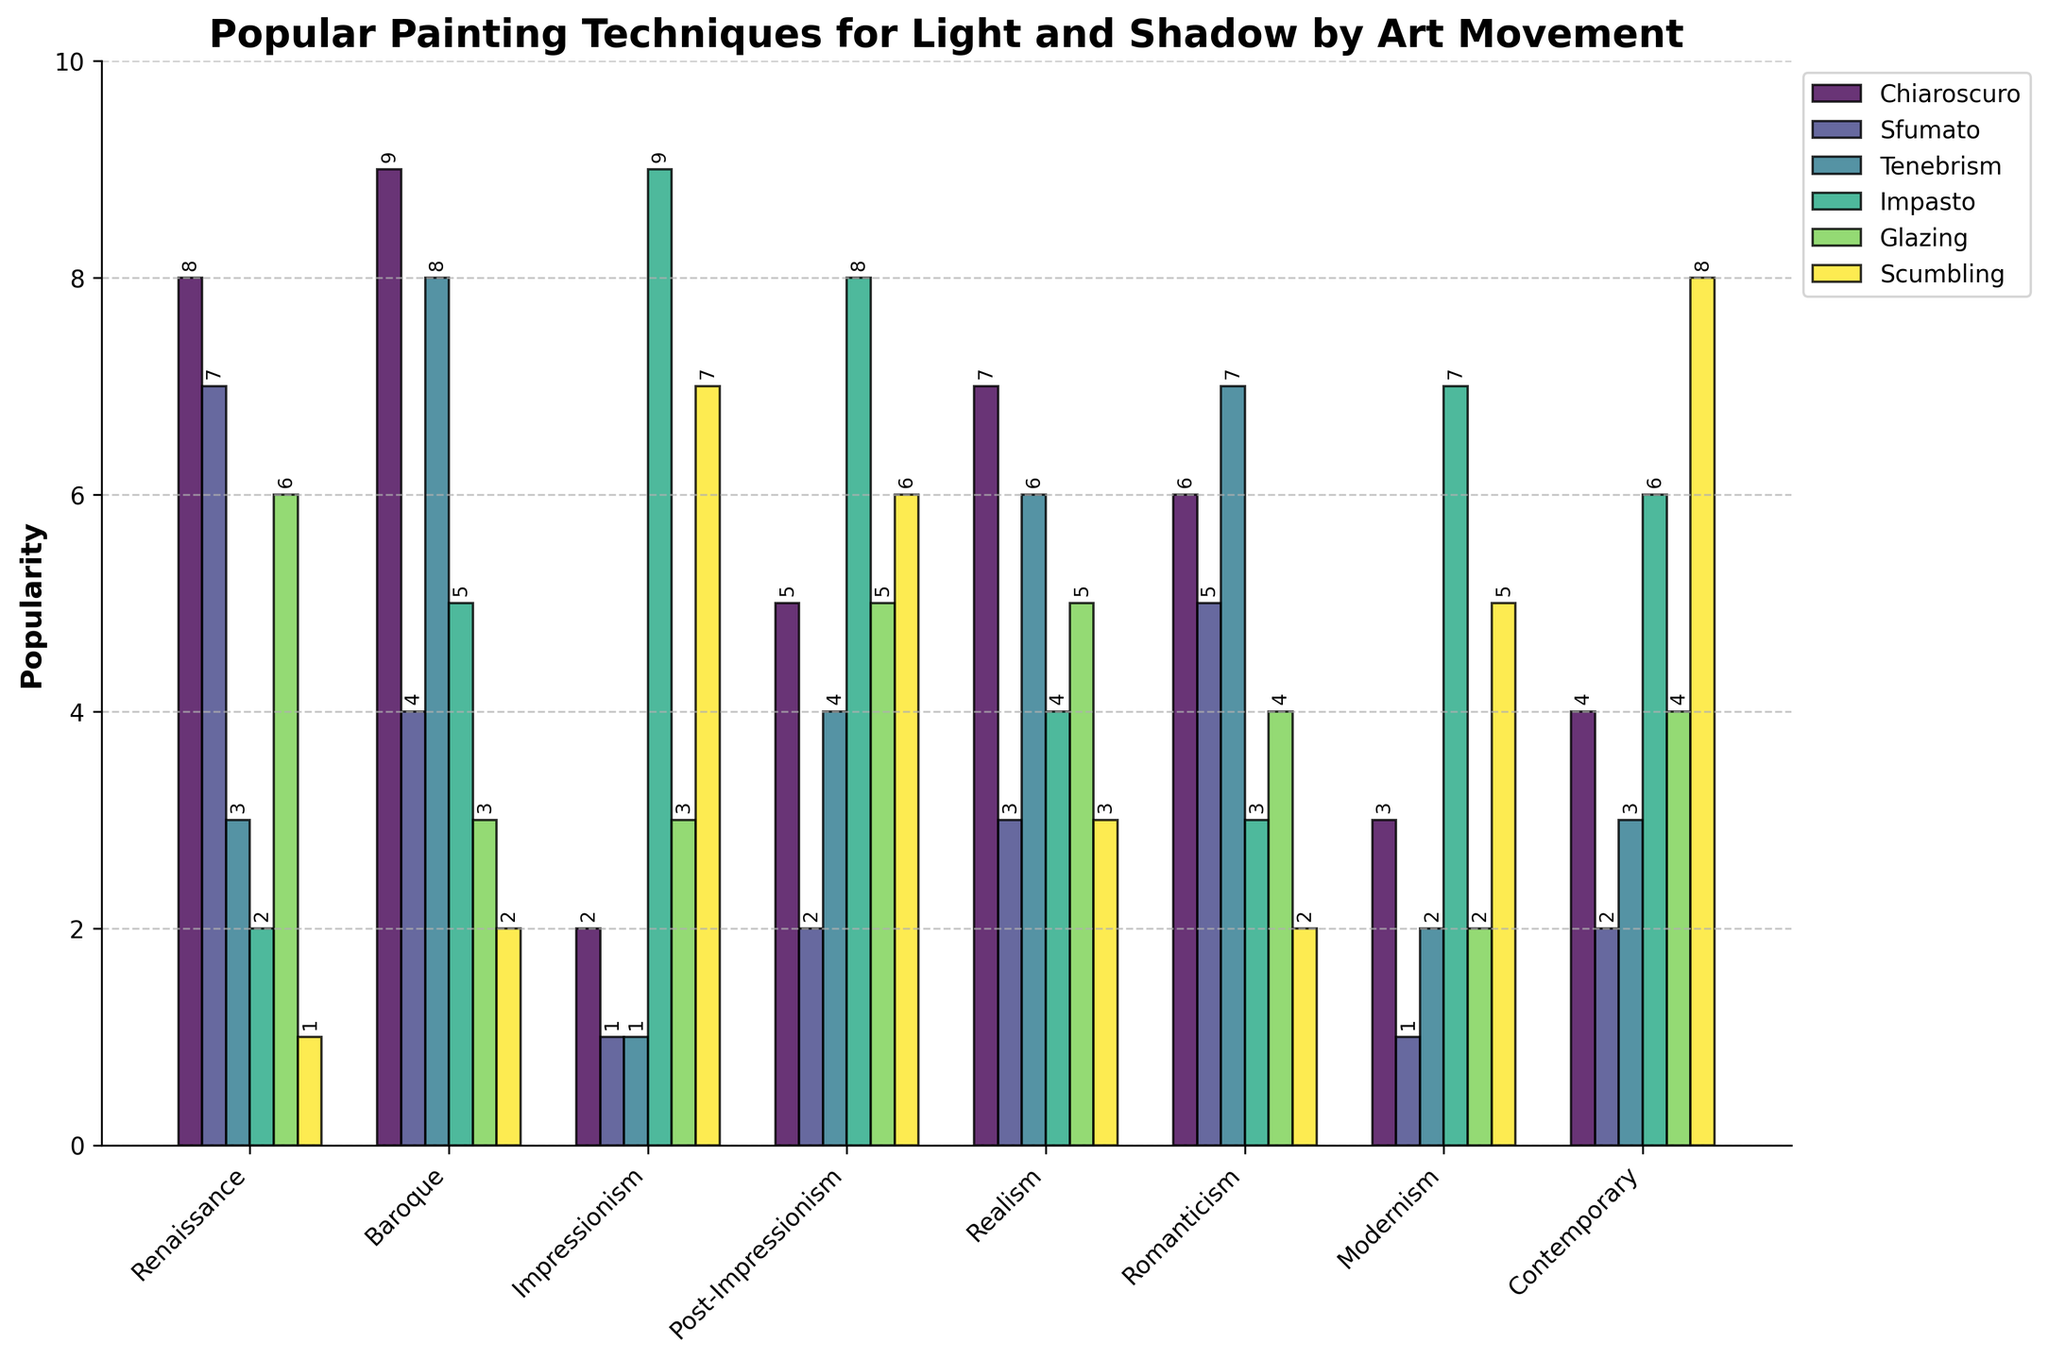What is the most popular painting technique used in the Baroque period? By examining the height of the bars for each technique in the Baroque period, we see that "Chiaroscuro" has the highest bar, which indicates it is the most popular technique.
Answer: Chiaroscuro Which art movement uses Impasto more frequently: Impressionism or Realism? Comparing the height of the Impasto bars for both movements, we see that the Impressionism bar is taller (9) than the Realism bar (4).
Answer: Impressionism In which art movement is Sfumato used the least? We need to find the shortest bar for Sfumato across all movements. The shortest bar corresponds to the Impressionism movement with a value of 1.
Answer: Impressionism What is the average popularity of Glazing across all art movements? Sum the values of Glazing across all movements (6+3+3+5+5+4+2+4) = 32, and then divide by the number of groups (8). The average is 32/8 = 4.
Answer: 4 How does the popularity of Tenebrism in Romanticism compare to that in Contemporary art? By comparing the height of the Tenebrism bars, Romanticism has a bar value of 7, and Contemporary has a bar value of 3, indicating that Tenebrism is more popular in Romanticism.
Answer: Romanticism is higher Which painting technique has a consistent popularity across all art movements, based on visual observation? Observing the bar heights visually, Scumbling appears relatively consistent, maintaining moderate values with minor variations.
Answer: Scumbling What is the total number of times Chiaroscuro is used in the Renaissance and Baroque periods combined? Adding the values of Chiaroscuro for both periods (8 for Renaissance + 9 for Baroque) gives us 17.
Answer: 17 How does the popularity of Scumbling in Contemporary art compare to its popularity in Modernism? Comparing the heights of the Scumbling bars, Contemporary has a value of 8, while Modernism has a value of 5, indicating it is more popular in Contemporary art.
Answer: Contemporary is higher Which art movement has the least variety in painting techniques, measured by the range (difference between maximum and minimum values)? Calculate the range for each movement by subtracting the minimum value from the maximum value and identify the smallest range. For instance, Renaissance has a range (8-1 = 7), Baroque (9-2 = 7), and so on. The minimum range is for Baroque and Renaissance, both having a range of 7.
Answer: Baroque, Renaissance Among all movements, which technique has the highest single value, indicating peak popularity? Identify the highest value from the bars for all techniques. The highest value is for Impasto in Impressionism, which is 9.
Answer: Impasto in Impressionism 